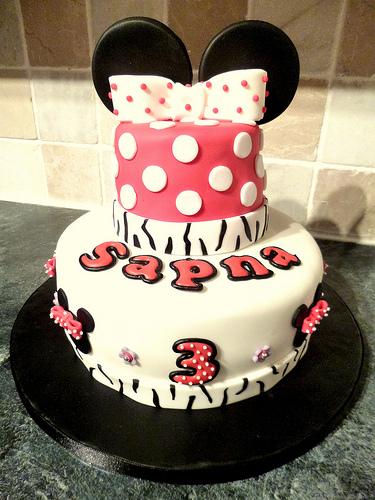<image>
Is there a cake on the table? Yes. Looking at the image, I can see the cake is positioned on top of the table, with the table providing support. Is there a bow behind the icing? Yes. From this viewpoint, the bow is positioned behind the icing, with the icing partially or fully occluding the bow. 